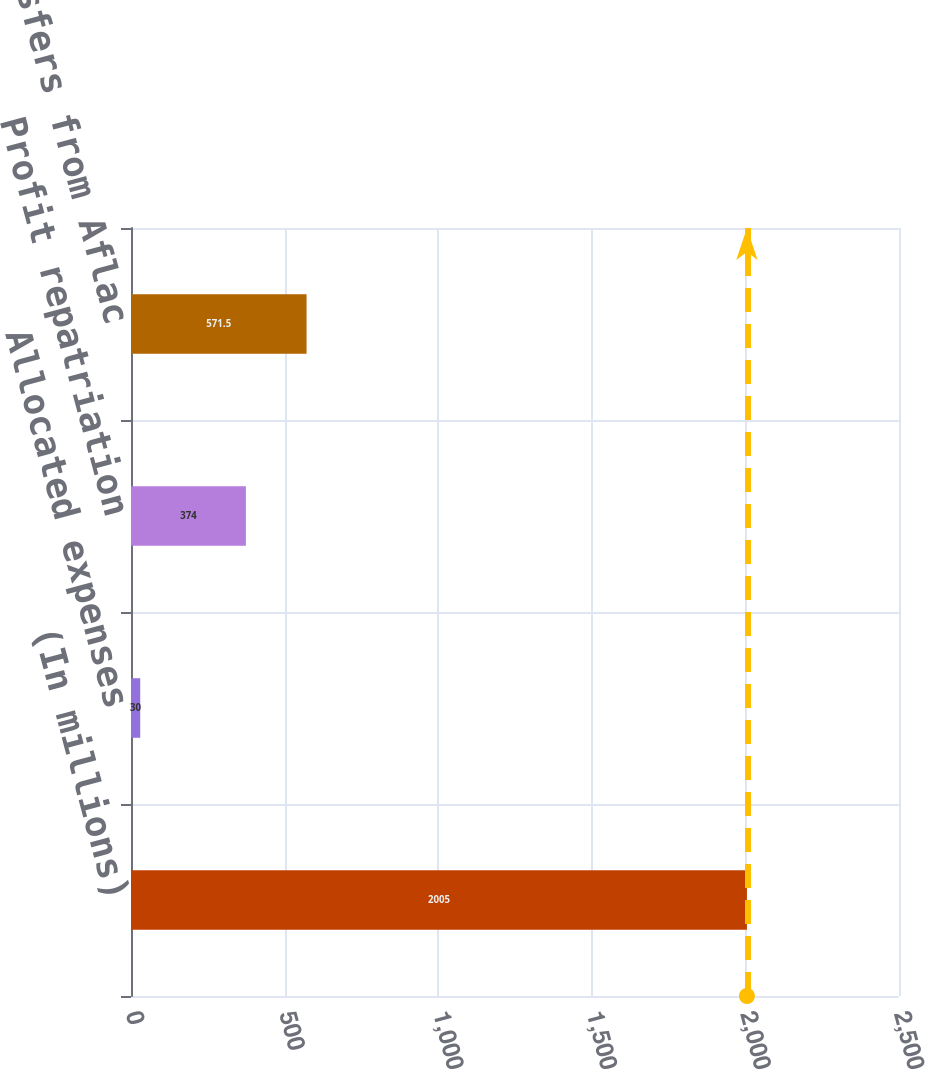Convert chart. <chart><loc_0><loc_0><loc_500><loc_500><bar_chart><fcel>(In millions)<fcel>Allocated expenses<fcel>Profit repatriation<fcel>Total transfers from Aflac<nl><fcel>2005<fcel>30<fcel>374<fcel>571.5<nl></chart> 